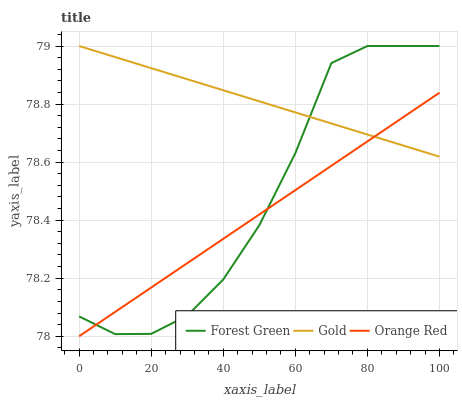Does Orange Red have the minimum area under the curve?
Answer yes or no. Yes. Does Gold have the maximum area under the curve?
Answer yes or no. Yes. Does Gold have the minimum area under the curve?
Answer yes or no. No. Does Orange Red have the maximum area under the curve?
Answer yes or no. No. Is Orange Red the smoothest?
Answer yes or no. Yes. Is Forest Green the roughest?
Answer yes or no. Yes. Is Gold the smoothest?
Answer yes or no. No. Is Gold the roughest?
Answer yes or no. No. Does Gold have the lowest value?
Answer yes or no. No. Does Gold have the highest value?
Answer yes or no. Yes. Does Orange Red have the highest value?
Answer yes or no. No. 